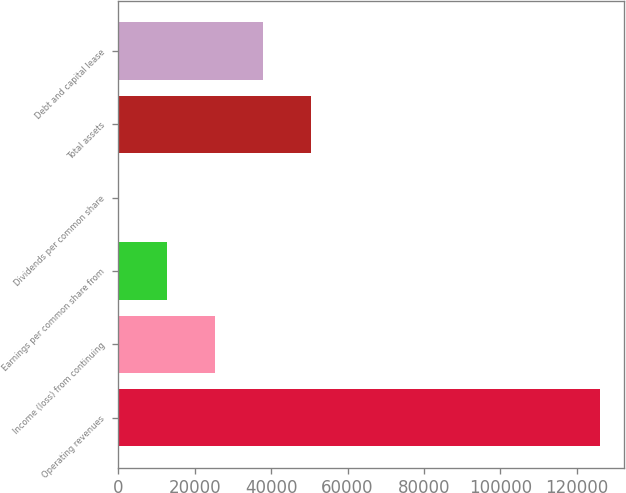<chart> <loc_0><loc_0><loc_500><loc_500><bar_chart><fcel>Operating revenues<fcel>Income (loss) from continuing<fcel>Earnings per common share from<fcel>Dividends per common share<fcel>Total assets<fcel>Debt and capital lease<nl><fcel>125987<fcel>25197.6<fcel>12599<fcel>0.3<fcel>50395<fcel>37796.3<nl></chart> 